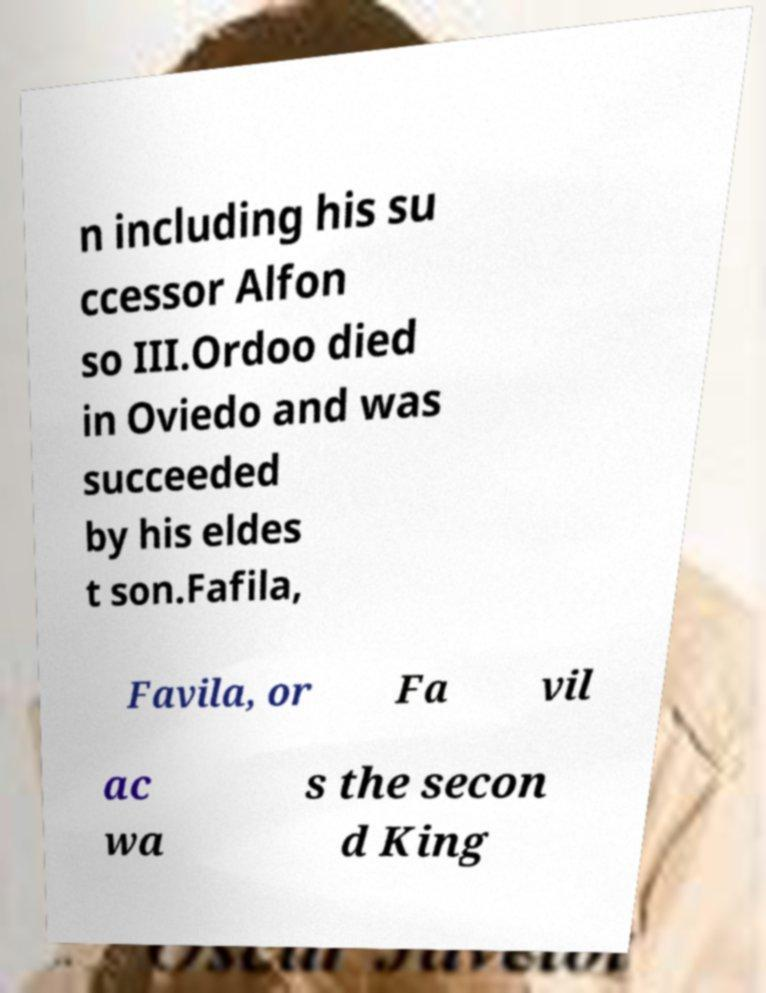Could you assist in decoding the text presented in this image and type it out clearly? n including his su ccessor Alfon so III.Ordoo died in Oviedo and was succeeded by his eldes t son.Fafila, Favila, or Fa vil ac wa s the secon d King 